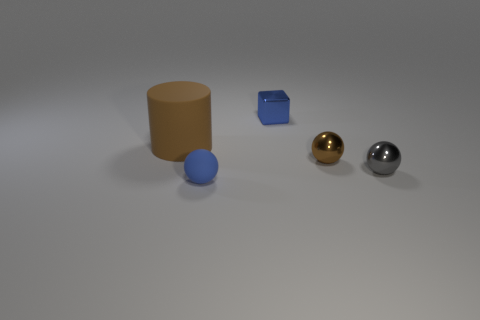Is there anything else that has the same material as the gray ball?
Give a very brief answer. Yes. Are there any other big red things made of the same material as the large thing?
Ensure brevity in your answer.  No. There is another tiny rubber object that is the same shape as the small gray thing; what is its color?
Provide a succinct answer. Blue. Are there fewer tiny brown balls that are in front of the small blue matte sphere than small brown metallic things on the right side of the small gray metallic ball?
Offer a terse response. No. What number of other things are the same shape as the small gray object?
Your answer should be compact. 2. Is the number of big rubber things to the left of the large brown rubber object less than the number of gray shiny things?
Your answer should be very brief. Yes. What is the material of the tiny blue thing that is in front of the blue metallic thing?
Keep it short and to the point. Rubber. What number of other things are there of the same size as the brown matte thing?
Your answer should be compact. 0. Is the number of matte cylinders less than the number of big blue spheres?
Your answer should be compact. No. The blue matte thing has what shape?
Ensure brevity in your answer.  Sphere. 